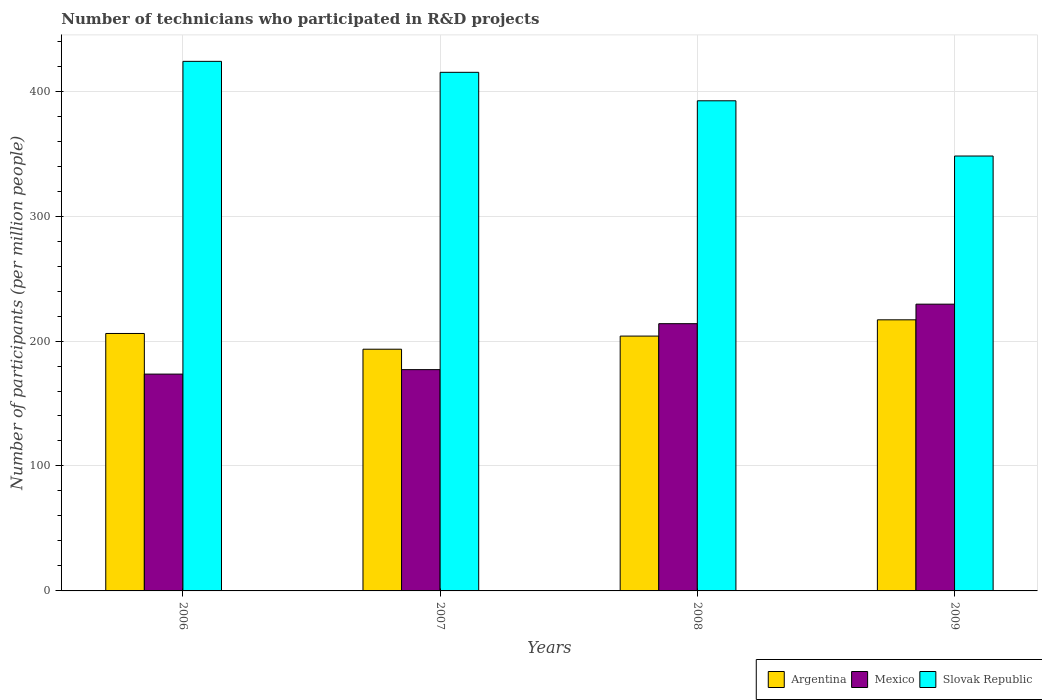How many different coloured bars are there?
Offer a terse response. 3. How many groups of bars are there?
Your answer should be compact. 4. Are the number of bars on each tick of the X-axis equal?
Make the answer very short. Yes. How many bars are there on the 1st tick from the right?
Your answer should be compact. 3. What is the label of the 1st group of bars from the left?
Offer a terse response. 2006. In how many cases, is the number of bars for a given year not equal to the number of legend labels?
Offer a very short reply. 0. What is the number of technicians who participated in R&D projects in Slovak Republic in 2008?
Give a very brief answer. 392.28. Across all years, what is the maximum number of technicians who participated in R&D projects in Slovak Republic?
Your answer should be compact. 423.83. Across all years, what is the minimum number of technicians who participated in R&D projects in Mexico?
Provide a short and direct response. 173.53. In which year was the number of technicians who participated in R&D projects in Argentina minimum?
Ensure brevity in your answer.  2007. What is the total number of technicians who participated in R&D projects in Argentina in the graph?
Provide a succinct answer. 820.41. What is the difference between the number of technicians who participated in R&D projects in Argentina in 2006 and that in 2009?
Make the answer very short. -10.92. What is the difference between the number of technicians who participated in R&D projects in Argentina in 2008 and the number of technicians who participated in R&D projects in Slovak Republic in 2009?
Make the answer very short. -144.11. What is the average number of technicians who participated in R&D projects in Mexico per year?
Keep it short and to the point. 198.5. In the year 2007, what is the difference between the number of technicians who participated in R&D projects in Slovak Republic and number of technicians who participated in R&D projects in Argentina?
Your response must be concise. 221.62. What is the ratio of the number of technicians who participated in R&D projects in Argentina in 2006 to that in 2008?
Provide a succinct answer. 1.01. What is the difference between the highest and the second highest number of technicians who participated in R&D projects in Mexico?
Provide a short and direct response. 15.61. What is the difference between the highest and the lowest number of technicians who participated in R&D projects in Slovak Republic?
Make the answer very short. 75.77. Is the sum of the number of technicians who participated in R&D projects in Mexico in 2006 and 2009 greater than the maximum number of technicians who participated in R&D projects in Argentina across all years?
Keep it short and to the point. Yes. What does the 2nd bar from the left in 2009 represents?
Provide a short and direct response. Mexico. What does the 1st bar from the right in 2007 represents?
Ensure brevity in your answer.  Slovak Republic. How many years are there in the graph?
Provide a succinct answer. 4. What is the difference between two consecutive major ticks on the Y-axis?
Provide a short and direct response. 100. Are the values on the major ticks of Y-axis written in scientific E-notation?
Your answer should be very brief. No. Does the graph contain any zero values?
Your answer should be compact. No. Does the graph contain grids?
Your response must be concise. Yes. Where does the legend appear in the graph?
Offer a terse response. Bottom right. What is the title of the graph?
Your response must be concise. Number of technicians who participated in R&D projects. Does "Georgia" appear as one of the legend labels in the graph?
Keep it short and to the point. No. What is the label or title of the Y-axis?
Your answer should be very brief. Number of participants (per million people). What is the Number of participants (per million people) in Argentina in 2006?
Ensure brevity in your answer.  206.05. What is the Number of participants (per million people) of Mexico in 2006?
Provide a succinct answer. 173.53. What is the Number of participants (per million people) of Slovak Republic in 2006?
Offer a terse response. 423.83. What is the Number of participants (per million people) in Argentina in 2007?
Your answer should be compact. 193.45. What is the Number of participants (per million people) of Mexico in 2007?
Offer a terse response. 177.1. What is the Number of participants (per million people) in Slovak Republic in 2007?
Give a very brief answer. 415.06. What is the Number of participants (per million people) of Argentina in 2008?
Keep it short and to the point. 203.95. What is the Number of participants (per million people) in Mexico in 2008?
Offer a very short reply. 213.89. What is the Number of participants (per million people) of Slovak Republic in 2008?
Provide a succinct answer. 392.28. What is the Number of participants (per million people) of Argentina in 2009?
Give a very brief answer. 216.97. What is the Number of participants (per million people) in Mexico in 2009?
Offer a very short reply. 229.5. What is the Number of participants (per million people) of Slovak Republic in 2009?
Your answer should be very brief. 348.06. Across all years, what is the maximum Number of participants (per million people) in Argentina?
Make the answer very short. 216.97. Across all years, what is the maximum Number of participants (per million people) of Mexico?
Offer a very short reply. 229.5. Across all years, what is the maximum Number of participants (per million people) of Slovak Republic?
Provide a succinct answer. 423.83. Across all years, what is the minimum Number of participants (per million people) of Argentina?
Give a very brief answer. 193.45. Across all years, what is the minimum Number of participants (per million people) in Mexico?
Your response must be concise. 173.53. Across all years, what is the minimum Number of participants (per million people) in Slovak Republic?
Make the answer very short. 348.06. What is the total Number of participants (per million people) of Argentina in the graph?
Offer a terse response. 820.41. What is the total Number of participants (per million people) in Mexico in the graph?
Offer a very short reply. 794.01. What is the total Number of participants (per million people) of Slovak Republic in the graph?
Keep it short and to the point. 1579.23. What is the difference between the Number of participants (per million people) of Argentina in 2006 and that in 2007?
Make the answer very short. 12.6. What is the difference between the Number of participants (per million people) of Mexico in 2006 and that in 2007?
Your response must be concise. -3.57. What is the difference between the Number of participants (per million people) in Slovak Republic in 2006 and that in 2007?
Offer a terse response. 8.77. What is the difference between the Number of participants (per million people) in Argentina in 2006 and that in 2008?
Your response must be concise. 2.1. What is the difference between the Number of participants (per million people) of Mexico in 2006 and that in 2008?
Provide a succinct answer. -40.36. What is the difference between the Number of participants (per million people) in Slovak Republic in 2006 and that in 2008?
Make the answer very short. 31.56. What is the difference between the Number of participants (per million people) of Argentina in 2006 and that in 2009?
Provide a short and direct response. -10.92. What is the difference between the Number of participants (per million people) in Mexico in 2006 and that in 2009?
Make the answer very short. -55.97. What is the difference between the Number of participants (per million people) of Slovak Republic in 2006 and that in 2009?
Ensure brevity in your answer.  75.77. What is the difference between the Number of participants (per million people) of Argentina in 2007 and that in 2008?
Provide a short and direct response. -10.51. What is the difference between the Number of participants (per million people) in Mexico in 2007 and that in 2008?
Offer a terse response. -36.79. What is the difference between the Number of participants (per million people) in Slovak Republic in 2007 and that in 2008?
Ensure brevity in your answer.  22.79. What is the difference between the Number of participants (per million people) in Argentina in 2007 and that in 2009?
Provide a short and direct response. -23.52. What is the difference between the Number of participants (per million people) of Mexico in 2007 and that in 2009?
Give a very brief answer. -52.4. What is the difference between the Number of participants (per million people) of Slovak Republic in 2007 and that in 2009?
Keep it short and to the point. 67. What is the difference between the Number of participants (per million people) in Argentina in 2008 and that in 2009?
Make the answer very short. -13.02. What is the difference between the Number of participants (per million people) of Mexico in 2008 and that in 2009?
Your answer should be compact. -15.61. What is the difference between the Number of participants (per million people) of Slovak Republic in 2008 and that in 2009?
Your answer should be very brief. 44.22. What is the difference between the Number of participants (per million people) in Argentina in 2006 and the Number of participants (per million people) in Mexico in 2007?
Your response must be concise. 28.95. What is the difference between the Number of participants (per million people) of Argentina in 2006 and the Number of participants (per million people) of Slovak Republic in 2007?
Offer a terse response. -209.01. What is the difference between the Number of participants (per million people) in Mexico in 2006 and the Number of participants (per million people) in Slovak Republic in 2007?
Offer a very short reply. -241.53. What is the difference between the Number of participants (per million people) of Argentina in 2006 and the Number of participants (per million people) of Mexico in 2008?
Provide a short and direct response. -7.84. What is the difference between the Number of participants (per million people) of Argentina in 2006 and the Number of participants (per million people) of Slovak Republic in 2008?
Your response must be concise. -186.23. What is the difference between the Number of participants (per million people) in Mexico in 2006 and the Number of participants (per million people) in Slovak Republic in 2008?
Provide a short and direct response. -218.75. What is the difference between the Number of participants (per million people) of Argentina in 2006 and the Number of participants (per million people) of Mexico in 2009?
Make the answer very short. -23.45. What is the difference between the Number of participants (per million people) in Argentina in 2006 and the Number of participants (per million people) in Slovak Republic in 2009?
Keep it short and to the point. -142.01. What is the difference between the Number of participants (per million people) in Mexico in 2006 and the Number of participants (per million people) in Slovak Republic in 2009?
Your answer should be compact. -174.53. What is the difference between the Number of participants (per million people) of Argentina in 2007 and the Number of participants (per million people) of Mexico in 2008?
Ensure brevity in your answer.  -20.44. What is the difference between the Number of participants (per million people) of Argentina in 2007 and the Number of participants (per million people) of Slovak Republic in 2008?
Ensure brevity in your answer.  -198.83. What is the difference between the Number of participants (per million people) in Mexico in 2007 and the Number of participants (per million people) in Slovak Republic in 2008?
Your answer should be compact. -215.18. What is the difference between the Number of participants (per million people) in Argentina in 2007 and the Number of participants (per million people) in Mexico in 2009?
Provide a short and direct response. -36.05. What is the difference between the Number of participants (per million people) of Argentina in 2007 and the Number of participants (per million people) of Slovak Republic in 2009?
Give a very brief answer. -154.61. What is the difference between the Number of participants (per million people) in Mexico in 2007 and the Number of participants (per million people) in Slovak Republic in 2009?
Your response must be concise. -170.96. What is the difference between the Number of participants (per million people) of Argentina in 2008 and the Number of participants (per million people) of Mexico in 2009?
Ensure brevity in your answer.  -25.55. What is the difference between the Number of participants (per million people) of Argentina in 2008 and the Number of participants (per million people) of Slovak Republic in 2009?
Make the answer very short. -144.11. What is the difference between the Number of participants (per million people) in Mexico in 2008 and the Number of participants (per million people) in Slovak Republic in 2009?
Your answer should be compact. -134.17. What is the average Number of participants (per million people) in Argentina per year?
Make the answer very short. 205.1. What is the average Number of participants (per million people) of Mexico per year?
Keep it short and to the point. 198.5. What is the average Number of participants (per million people) in Slovak Republic per year?
Your response must be concise. 394.81. In the year 2006, what is the difference between the Number of participants (per million people) of Argentina and Number of participants (per million people) of Mexico?
Keep it short and to the point. 32.52. In the year 2006, what is the difference between the Number of participants (per million people) of Argentina and Number of participants (per million people) of Slovak Republic?
Ensure brevity in your answer.  -217.79. In the year 2006, what is the difference between the Number of participants (per million people) of Mexico and Number of participants (per million people) of Slovak Republic?
Your answer should be very brief. -250.31. In the year 2007, what is the difference between the Number of participants (per million people) of Argentina and Number of participants (per million people) of Mexico?
Provide a short and direct response. 16.35. In the year 2007, what is the difference between the Number of participants (per million people) in Argentina and Number of participants (per million people) in Slovak Republic?
Make the answer very short. -221.62. In the year 2007, what is the difference between the Number of participants (per million people) of Mexico and Number of participants (per million people) of Slovak Republic?
Keep it short and to the point. -237.96. In the year 2008, what is the difference between the Number of participants (per million people) in Argentina and Number of participants (per million people) in Mexico?
Offer a very short reply. -9.93. In the year 2008, what is the difference between the Number of participants (per million people) of Argentina and Number of participants (per million people) of Slovak Republic?
Provide a short and direct response. -188.32. In the year 2008, what is the difference between the Number of participants (per million people) in Mexico and Number of participants (per million people) in Slovak Republic?
Your response must be concise. -178.39. In the year 2009, what is the difference between the Number of participants (per million people) of Argentina and Number of participants (per million people) of Mexico?
Provide a succinct answer. -12.53. In the year 2009, what is the difference between the Number of participants (per million people) of Argentina and Number of participants (per million people) of Slovak Republic?
Make the answer very short. -131.09. In the year 2009, what is the difference between the Number of participants (per million people) in Mexico and Number of participants (per million people) in Slovak Republic?
Your answer should be compact. -118.56. What is the ratio of the Number of participants (per million people) in Argentina in 2006 to that in 2007?
Your answer should be compact. 1.07. What is the ratio of the Number of participants (per million people) in Mexico in 2006 to that in 2007?
Offer a terse response. 0.98. What is the ratio of the Number of participants (per million people) in Slovak Republic in 2006 to that in 2007?
Provide a short and direct response. 1.02. What is the ratio of the Number of participants (per million people) of Argentina in 2006 to that in 2008?
Keep it short and to the point. 1.01. What is the ratio of the Number of participants (per million people) in Mexico in 2006 to that in 2008?
Keep it short and to the point. 0.81. What is the ratio of the Number of participants (per million people) in Slovak Republic in 2006 to that in 2008?
Your response must be concise. 1.08. What is the ratio of the Number of participants (per million people) in Argentina in 2006 to that in 2009?
Make the answer very short. 0.95. What is the ratio of the Number of participants (per million people) of Mexico in 2006 to that in 2009?
Provide a succinct answer. 0.76. What is the ratio of the Number of participants (per million people) in Slovak Republic in 2006 to that in 2009?
Ensure brevity in your answer.  1.22. What is the ratio of the Number of participants (per million people) in Argentina in 2007 to that in 2008?
Offer a very short reply. 0.95. What is the ratio of the Number of participants (per million people) of Mexico in 2007 to that in 2008?
Ensure brevity in your answer.  0.83. What is the ratio of the Number of participants (per million people) of Slovak Republic in 2007 to that in 2008?
Provide a short and direct response. 1.06. What is the ratio of the Number of participants (per million people) in Argentina in 2007 to that in 2009?
Ensure brevity in your answer.  0.89. What is the ratio of the Number of participants (per million people) in Mexico in 2007 to that in 2009?
Keep it short and to the point. 0.77. What is the ratio of the Number of participants (per million people) in Slovak Republic in 2007 to that in 2009?
Offer a terse response. 1.19. What is the ratio of the Number of participants (per million people) in Argentina in 2008 to that in 2009?
Your answer should be very brief. 0.94. What is the ratio of the Number of participants (per million people) in Mexico in 2008 to that in 2009?
Your answer should be very brief. 0.93. What is the ratio of the Number of participants (per million people) of Slovak Republic in 2008 to that in 2009?
Keep it short and to the point. 1.13. What is the difference between the highest and the second highest Number of participants (per million people) of Argentina?
Ensure brevity in your answer.  10.92. What is the difference between the highest and the second highest Number of participants (per million people) of Mexico?
Offer a very short reply. 15.61. What is the difference between the highest and the second highest Number of participants (per million people) of Slovak Republic?
Provide a succinct answer. 8.77. What is the difference between the highest and the lowest Number of participants (per million people) in Argentina?
Offer a very short reply. 23.52. What is the difference between the highest and the lowest Number of participants (per million people) in Mexico?
Offer a very short reply. 55.97. What is the difference between the highest and the lowest Number of participants (per million people) in Slovak Republic?
Provide a short and direct response. 75.77. 